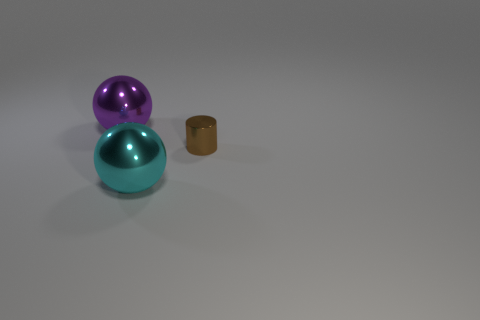Add 1 large cyan spheres. How many objects exist? 4 Subtract all balls. How many objects are left? 1 Add 1 green cubes. How many green cubes exist? 1 Subtract 0 cyan blocks. How many objects are left? 3 Subtract all purple shiny spheres. Subtract all cyan spheres. How many objects are left? 1 Add 1 large cyan spheres. How many large cyan spheres are left? 2 